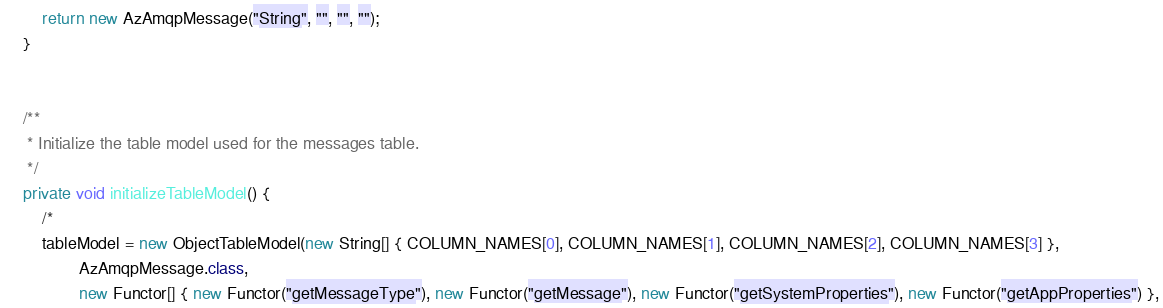Convert code to text. <code><loc_0><loc_0><loc_500><loc_500><_Java_>        return new AzAmqpMessage("String", "", "", "");
    }
    

    /**
     * Initialize the table model used for the messages table.
     */
    private void initializeTableModel() {
        /*
        tableModel = new ObjectTableModel(new String[] { COLUMN_NAMES[0], COLUMN_NAMES[1], COLUMN_NAMES[2], COLUMN_NAMES[3] },
                AzAmqpMessage.class,
                new Functor[] { new Functor("getMessageType"), new Functor("getMessage"), new Functor("getSystemProperties"), new Functor("getAppProperties") },</code> 